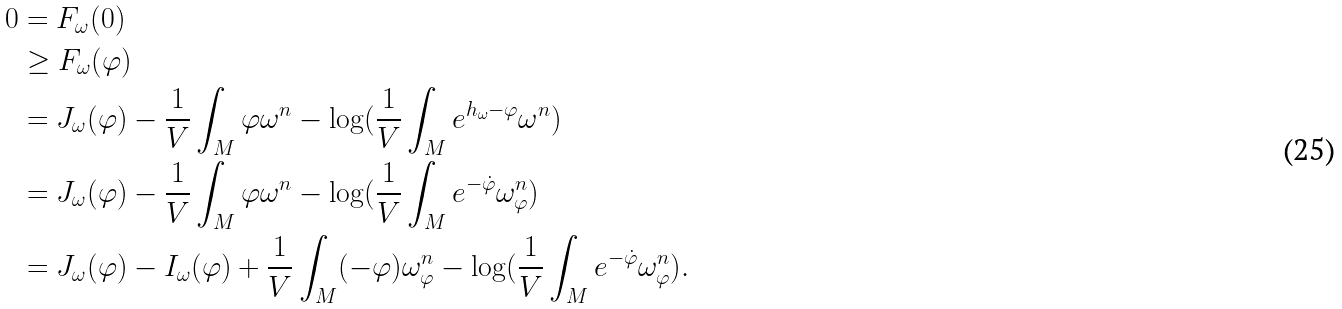<formula> <loc_0><loc_0><loc_500><loc_500>0 & = F _ { \omega } ( 0 ) \\ & \geq F _ { \omega } ( \varphi ) \\ & = J _ { \omega } ( \varphi ) - \frac { 1 } { V } \int _ { M } \varphi \omega ^ { n } - \log ( \frac { 1 } { V } \int _ { M } e ^ { h _ { \omega } - \varphi } \omega ^ { n } ) \\ & = J _ { \omega } ( \varphi ) - \frac { 1 } { V } \int _ { M } \varphi \omega ^ { n } - \log ( \frac { 1 } { V } \int _ { M } e ^ { - \dot { \varphi } } \omega _ { \varphi } ^ { n } ) \\ & = J _ { \omega } ( \varphi ) - I _ { \omega } ( \varphi ) + \frac { 1 } { V } \int _ { M } ( - \varphi ) \omega _ { \varphi } ^ { n } - \log ( \frac { 1 } { V } \int _ { M } e ^ { - \dot { \varphi } } \omega _ { \varphi } ^ { n } ) .</formula> 